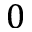Convert formula to latex. <formula><loc_0><loc_0><loc_500><loc_500>0</formula> 